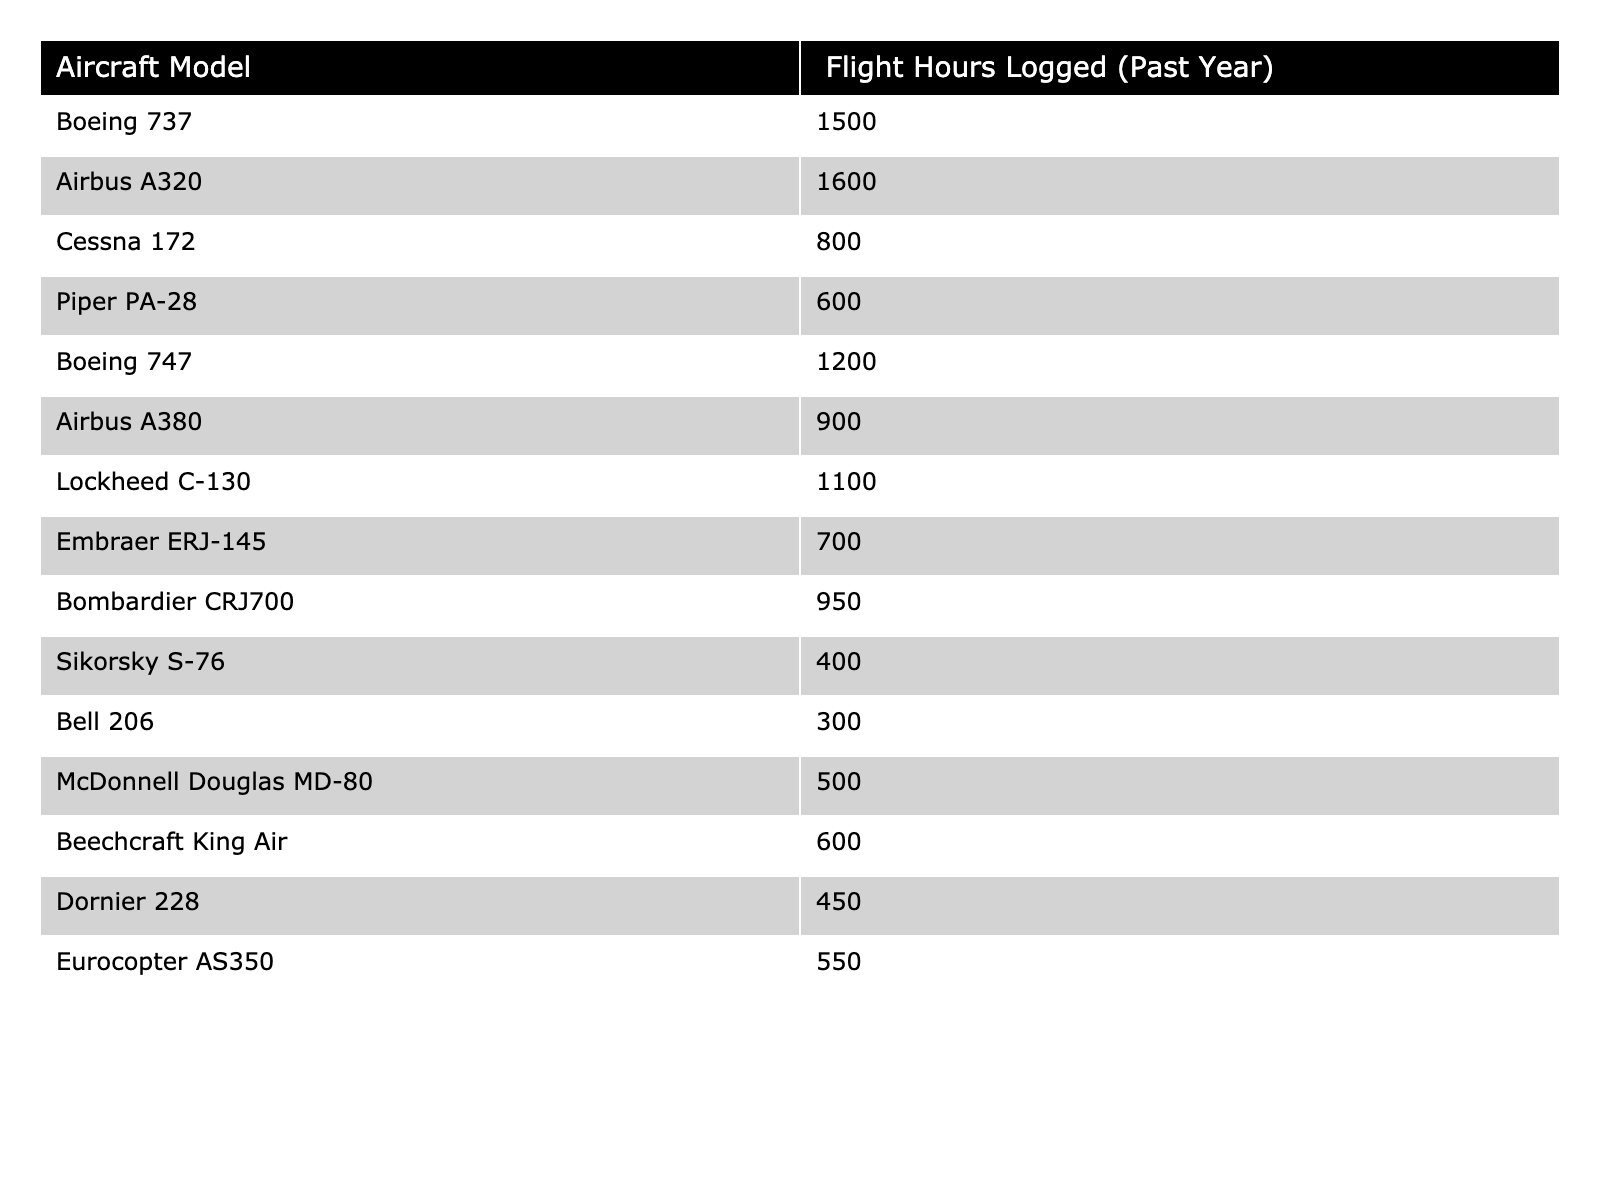What is the total flight hours logged by all aircraft models? To find the total flight hours, add all the logged hours for each aircraft model: 1500 + 1600 + 800 + 600 + 1200 + 900 + 1100 + 700 + 950 + 400 + 300 + 500 + 600 + 450 + 550 = 10300.
Answer: 10300 Which aircraft model logged the most flight hours? By reviewing the flight hours logged, the Boeing 737 at 1500 hours has the highest number, surpassing the Airbus A320 at 1600 hours.
Answer: Airbus A320 What is the average flight hours logged by the aircraft models listed? To find the average, sum the flight hours (10300) and divide by the number of aircraft models (15): 10300 / 15 = 686.67.
Answer: 686.67 Did the Cessna 172 log more flight hours than the Piper PA-28? Comparing the flight hours for the two: Cessna 172 logged 800 hours and Piper PA-28 logged 600 hours, thus Cessna 172 logged more hours.
Answer: Yes How many aircraft models logged more than 900 flight hours? From the table, the models logging more than 900 hours are: Boeing 737, Airbus A320, Boeing 747, Lockheed C-130, Bombardier CRJ700, and Airbus A380, which totals to 6 models.
Answer: 6 What is the difference in flight hours logged between the Boeing 737 and the Lockheed C-130? The Boeing 737 logged 1500 hours, while the Lockheed C-130 logged 1100 hours. The difference is 1500 - 1100 = 400 hours.
Answer: 400 Which aircraft logged the least amount of flight hours? By examining the table, the Bell 206 logged only 300 hours, which is the lowest among all models listed.
Answer: Bell 206 If we combine the flight hours of the Boeing 737, Airbus A320, and Boeing 747, what is the total? The total flight hours for these aircraft are: 1500 (Boeing 737) + 1600 (Airbus A320) + 1200 (Boeing 747) = 4300 hours.
Answer: 4300 Provide the median flight hours logged by the aircraft models. To find the median, we first list the flight hours in ascending order. The sorted list is: 300, 400, 450, 500, 550, 600, 600, 700, 800, 900, 950, 1100, 1200, 1500, 1600. The median (middle value) is the average of the 7th and 8th values: (600 + 700)/2 = 650.
Answer: 650 How many aircraft logged fewer than 600 flight hours? From the table, the aircraft that logged below 600 hours are the Piper PA-28 (600), Sikorsky S-76 (400), and Bell 206 (300) which count to 3 models that logged fewer than 600 hours.
Answer: 3 